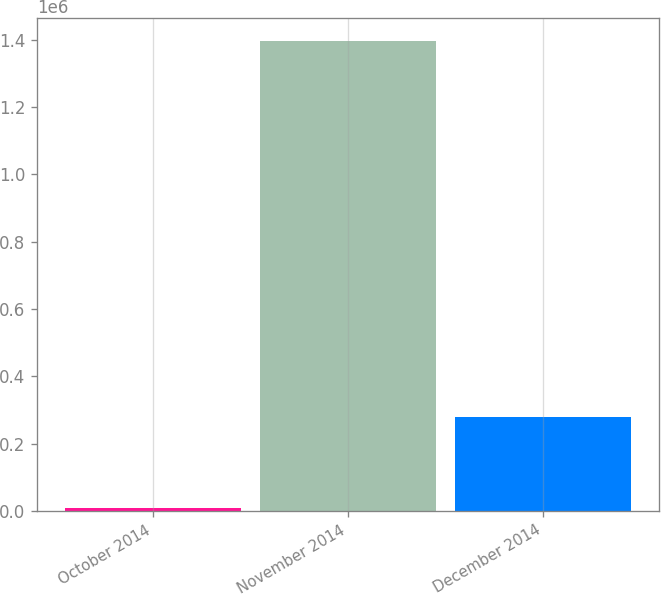Convert chart. <chart><loc_0><loc_0><loc_500><loc_500><bar_chart><fcel>October 2014<fcel>November 2014<fcel>December 2014<nl><fcel>7862<fcel>1.39573e+06<fcel>279982<nl></chart> 